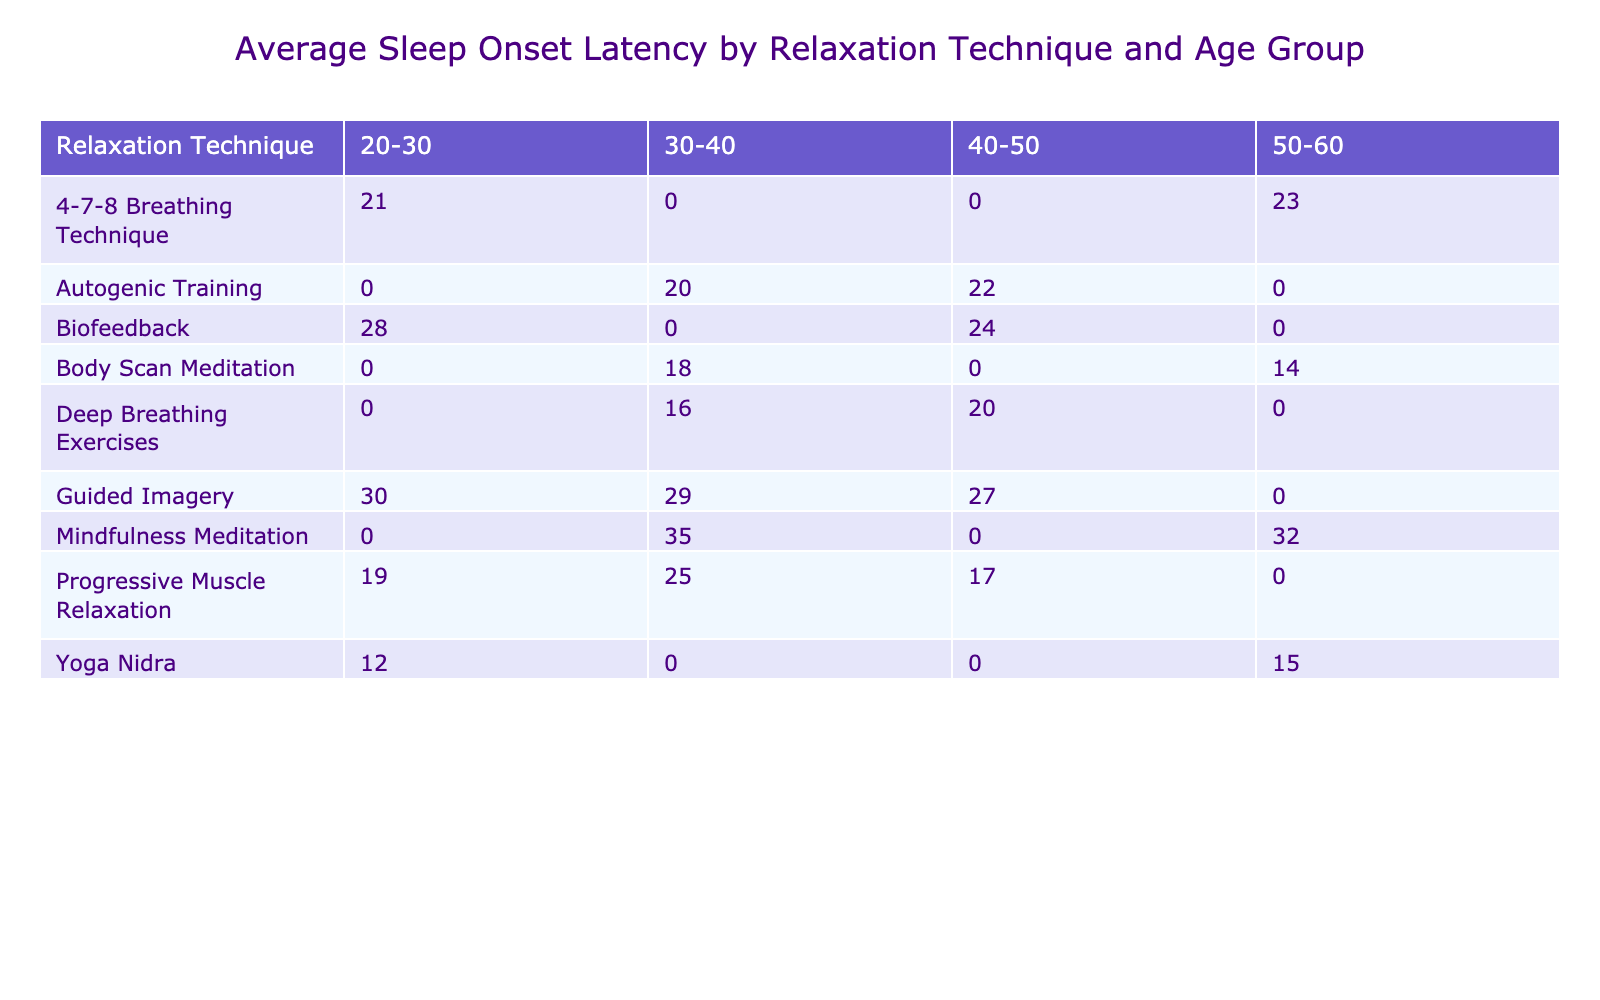What is the average sleep onset latency for Yoga Nidra in the 50-60 age group? The table shows the sleep onset latencies for Yoga Nidra: 15 minutes in the 50-60 age group. Since there is only one entry for this technique in that age category, the average is simply that value: 15.
Answer: 15 Which relaxation technique has the highest average sleep onset latency in the 30-40 age group? In the 30-40 age group, the average latencies for the techniques are: Progressive Muscle Relaxation (25), Mindfulness Meditation (35), Body Scan Meditation (18), and Guided Imagery (29). The highest among these is Mindfulness Meditation at 35 minutes.
Answer: 35 Is it true that Deep Breathing Exercises have an average sleep onset latency lower than 20 minutes? Reviewing the data, Deep Breathing Exercises have an average latency of 18 minutes in the 30-40 age group and 16 minutes in the other specified entries, thus the average is higher than 20 minutes. Therefore, the statement is false.
Answer: No What is the average sleep onset latency for Progressive Muscle Relaxation across all age groups? For Progressive Muscle Relaxation, the latencies are 25, 19, and 17 minutes across different age groups. To find the average, add these values: 25 + 19 + 17 = 61, then divide by the number of entries (3), which gives an average of 20.3 minutes.
Answer: 20.3 In total, how many relaxation techniques have an average sleep onset latency below 20 minutes? Analyzing the table, the techniques with latencies below 20 minutes are Yoga Nidra (15), Deep Breathing Exercises (16), and Body Scan Meditation (14). Therefore, there are three techniques that fit this criterion.
Answer: 3 What is the difference in average sleep onset latency between the highest and lowest techniques in the 50-60 age group? In the 50-60 age group, Yoga Nidra has the lowest latency at 15 minutes, and Mindfulness Meditation has the highest at 35 minutes. The difference is calculated as 35 - 15 = 20 minutes.
Answer: 20 What is the average anxiety level for relaxation techniques that have an average sleep onset latency greater than 25 minutes? The techniques with latencies greater than 25 minutes are Progressive Muscle Relaxation (25), Guided Imagery (30), Mindfulness Meditation (35), and Biofeedback (28). Their anxiety levels are 7, 8, 9, and 7 respectively. The average is (7 + 8 + 9 + 7) / 4 = 7.75.
Answer: 7.75 